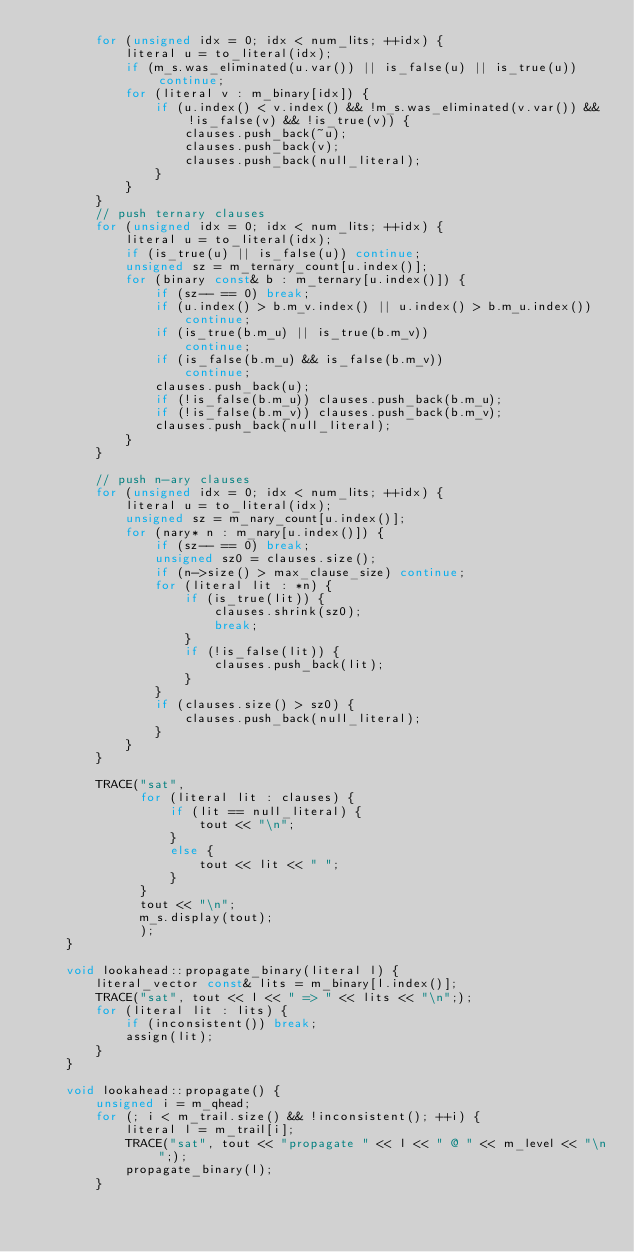<code> <loc_0><loc_0><loc_500><loc_500><_C++_>        for (unsigned idx = 0; idx < num_lits; ++idx) {
            literal u = to_literal(idx);
            if (m_s.was_eliminated(u.var()) || is_false(u) || is_true(u)) continue;
            for (literal v : m_binary[idx]) {
                if (u.index() < v.index() && !m_s.was_eliminated(v.var()) && !is_false(v) && !is_true(v)) {
                    clauses.push_back(~u);
                    clauses.push_back(v);
                    clauses.push_back(null_literal);
                }
            }
        }
        // push ternary clauses
        for (unsigned idx = 0; idx < num_lits; ++idx) {
            literal u = to_literal(idx);
            if (is_true(u) || is_false(u)) continue;
            unsigned sz = m_ternary_count[u.index()];
            for (binary const& b : m_ternary[u.index()]) {
                if (sz-- == 0) break;
                if (u.index() > b.m_v.index() || u.index() > b.m_u.index())
                    continue;
                if (is_true(b.m_u) || is_true(b.m_v)) 
                    continue;
                if (is_false(b.m_u) && is_false(b.m_v))
                    continue;
                clauses.push_back(u);
                if (!is_false(b.m_u)) clauses.push_back(b.m_u);
                if (!is_false(b.m_v)) clauses.push_back(b.m_v);
                clauses.push_back(null_literal);            
            }
        }

        // push n-ary clauses
        for (unsigned idx = 0; idx < num_lits; ++idx) {
            literal u = to_literal(idx);
            unsigned sz = m_nary_count[u.index()];
            for (nary* n : m_nary[u.index()]) {
                if (sz-- == 0) break;
                unsigned sz0 = clauses.size();
                if (n->size() > max_clause_size) continue;
                for (literal lit : *n) {
                    if (is_true(lit)) {
                        clauses.shrink(sz0);
                        break;
                    }
                    if (!is_false(lit)) { 
                        clauses.push_back(lit);
                    }
                }
                if (clauses.size() > sz0) {
                    clauses.push_back(null_literal);
                }
            }
        }

        TRACE("sat",
              for (literal lit : clauses) {
                  if (lit == null_literal) {
                      tout << "\n";
                  }
                  else {
                      tout << lit << " ";
                  }
              }
              tout << "\n";
              m_s.display(tout);
              );
    }

    void lookahead::propagate_binary(literal l) {
        literal_vector const& lits = m_binary[l.index()];
        TRACE("sat", tout << l << " => " << lits << "\n";);
        for (literal lit : lits) {
            if (inconsistent()) break;
            assign(lit);
        }
    }

    void lookahead::propagate() {
        unsigned i = m_qhead;
        for (; i < m_trail.size() && !inconsistent(); ++i) {
            literal l = m_trail[i];
            TRACE("sat", tout << "propagate " << l << " @ " << m_level << "\n";);
            propagate_binary(l);
        }</code> 